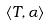Convert formula to latex. <formula><loc_0><loc_0><loc_500><loc_500>\langle T , \alpha \rangle</formula> 